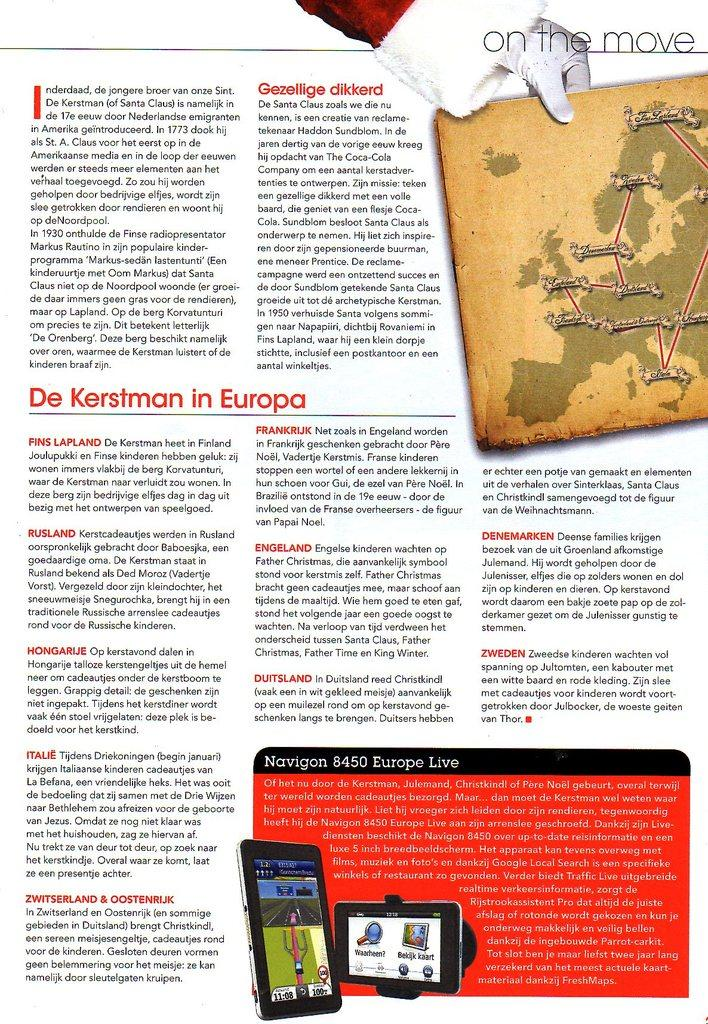<image>
Write a terse but informative summary of the picture. A page from a magazine titled On the Move in the upper right corner. 